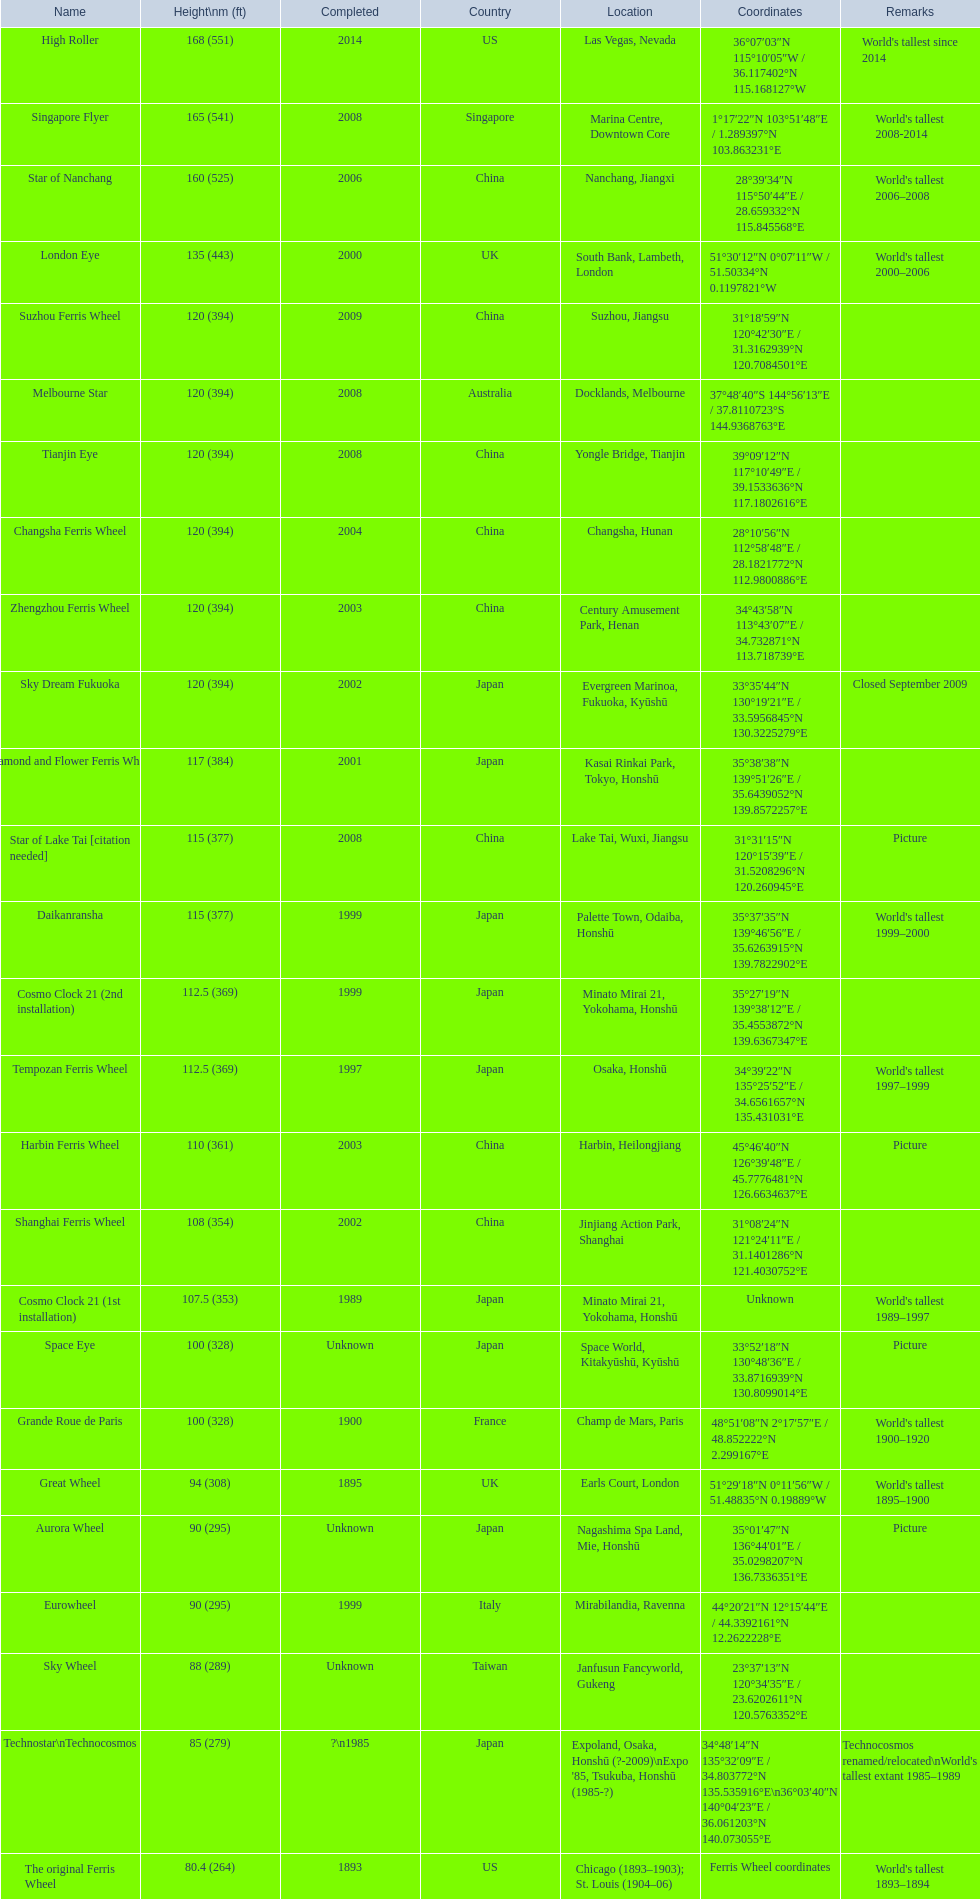How tall is the roller coaster star of nanchang? 165 (541). When was the roller coaster star of nanchang completed? 2008. What is the name of the oldest roller coaster? Star of Nanchang. 